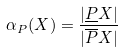Convert formula to latex. <formula><loc_0><loc_0><loc_500><loc_500>\alpha _ { P } ( X ) = \frac { | \underline { P } X | } { | \overline { P } X | }</formula> 